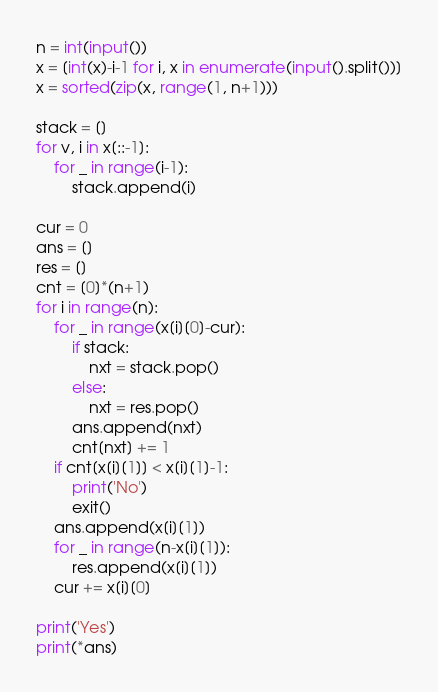Convert code to text. <code><loc_0><loc_0><loc_500><loc_500><_Python_>n = int(input())
x = [int(x)-i-1 for i, x in enumerate(input().split())]
x = sorted(zip(x, range(1, n+1)))

stack = []
for v, i in x[::-1]:
    for _ in range(i-1):
        stack.append(i)

cur = 0
ans = []
res = []
cnt = [0]*(n+1)
for i in range(n):
    for _ in range(x[i][0]-cur):
        if stack:
            nxt = stack.pop()
        else:
            nxt = res.pop()
        ans.append(nxt)
        cnt[nxt] += 1
    if cnt[x[i][1]] < x[i][1]-1:
        print('No')
        exit()
    ans.append(x[i][1])
    for _ in range(n-x[i][1]):
        res.append(x[i][1])
    cur += x[i][0]

print('Yes')
print(*ans)
</code> 